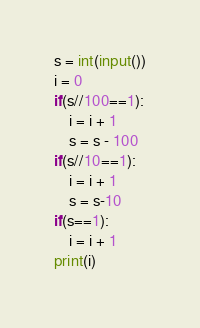<code> <loc_0><loc_0><loc_500><loc_500><_Python_>s = int(input())
i = 0
if(s//100==1):
    i = i + 1
    s = s - 100
if(s//10==1):
    i = i + 1
    s = s-10
if(s==1):
    i = i + 1
print(i)</code> 